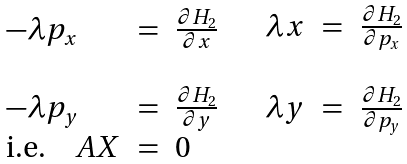Convert formula to latex. <formula><loc_0><loc_0><loc_500><loc_500>\begin{array} { l c l } - \lambda p _ { x } & = & \frac { \partial { H _ { 2 } } } { \partial x } \\ & & \\ - \lambda p _ { y } & = & \frac { \partial { H _ { 2 } } } { \partial y } \\ \text {i.e.} \quad A X & = & 0 \end{array} \quad \begin{array} { l c l } \lambda x & = & \frac { \partial { H _ { 2 } } } { \partial p _ { x } } \\ & & \\ \lambda y & = & \frac { \partial { H _ { 2 } } } { \partial p _ { y } } \\ & & \end{array}</formula> 